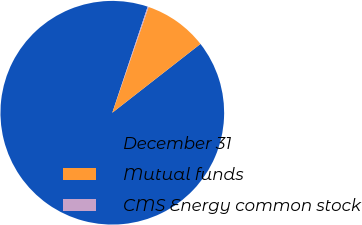Convert chart to OTSL. <chart><loc_0><loc_0><loc_500><loc_500><pie_chart><fcel>December 31<fcel>Mutual funds<fcel>CMS Energy common stock<nl><fcel>90.68%<fcel>9.19%<fcel>0.14%<nl></chart> 